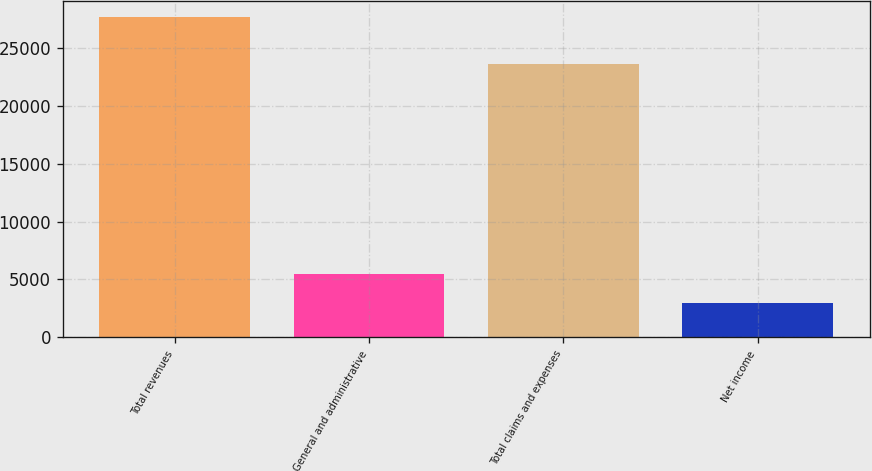<chart> <loc_0><loc_0><loc_500><loc_500><bar_chart><fcel>Total revenues<fcel>General and administrative<fcel>Total claims and expenses<fcel>Net income<nl><fcel>27625<fcel>5475.1<fcel>23572<fcel>3014<nl></chart> 